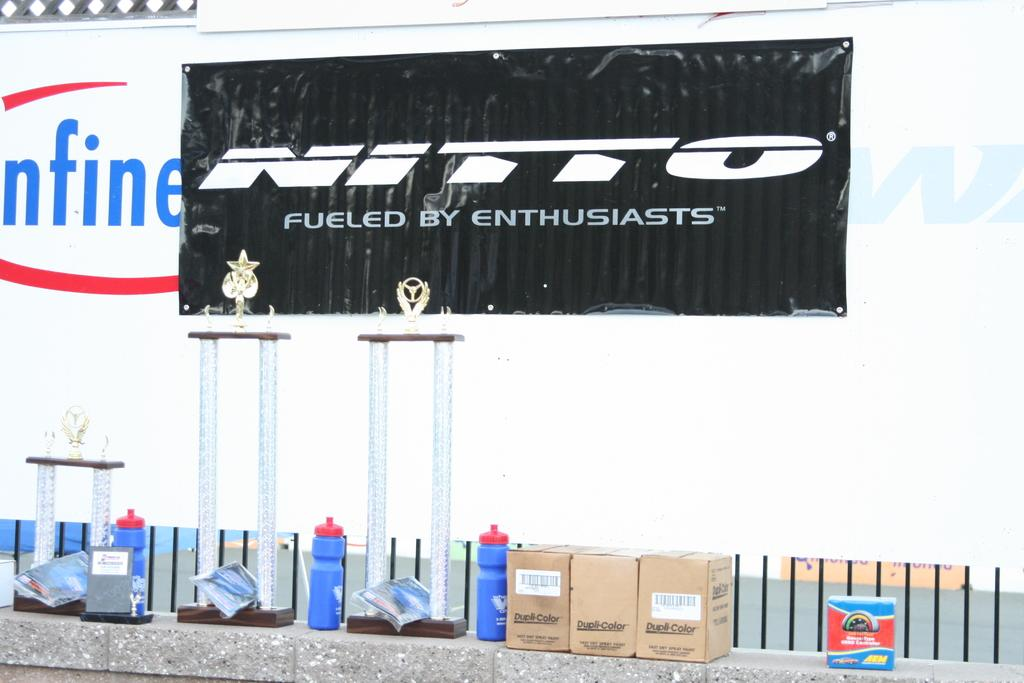<image>
Share a concise interpretation of the image provided. Black sign saying Nitto Fueld By Enthusiasts on top of a white wall. 